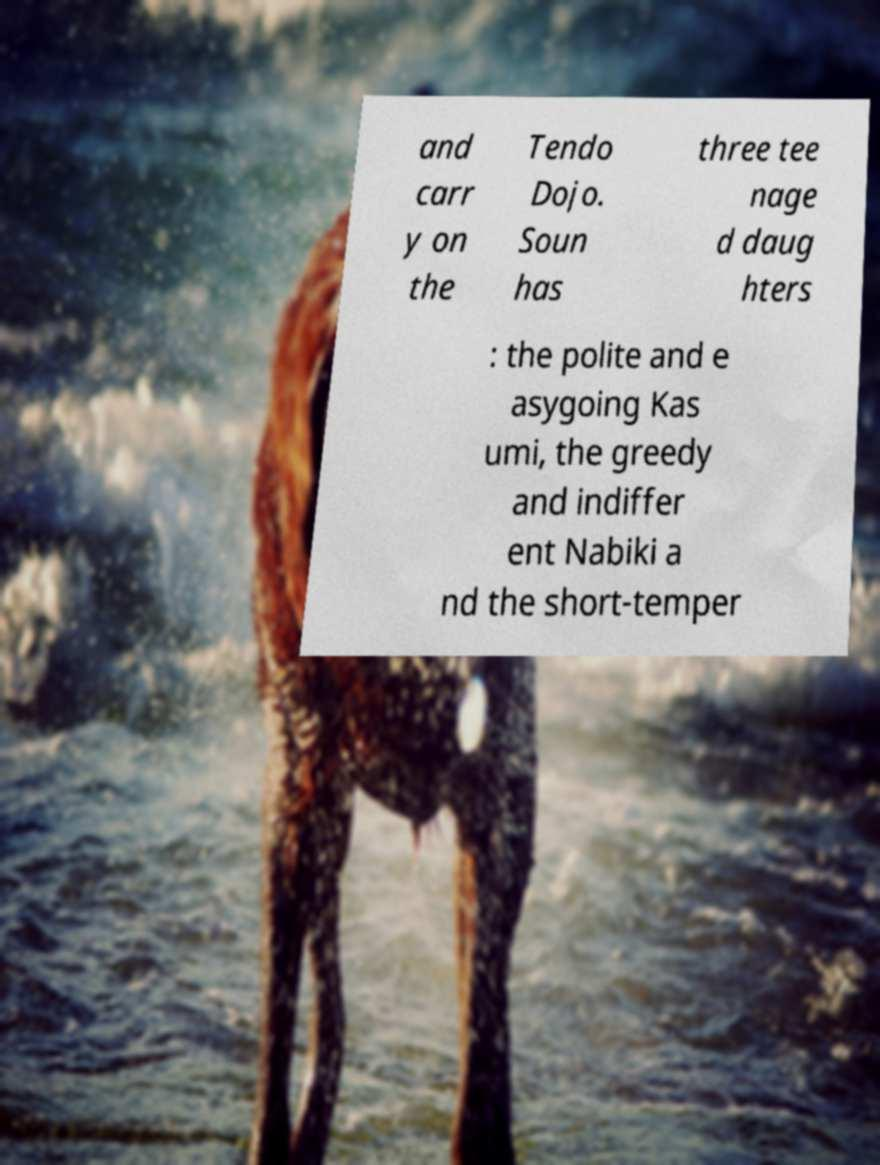I need the written content from this picture converted into text. Can you do that? and carr y on the Tendo Dojo. Soun has three tee nage d daug hters : the polite and e asygoing Kas umi, the greedy and indiffer ent Nabiki a nd the short-temper 